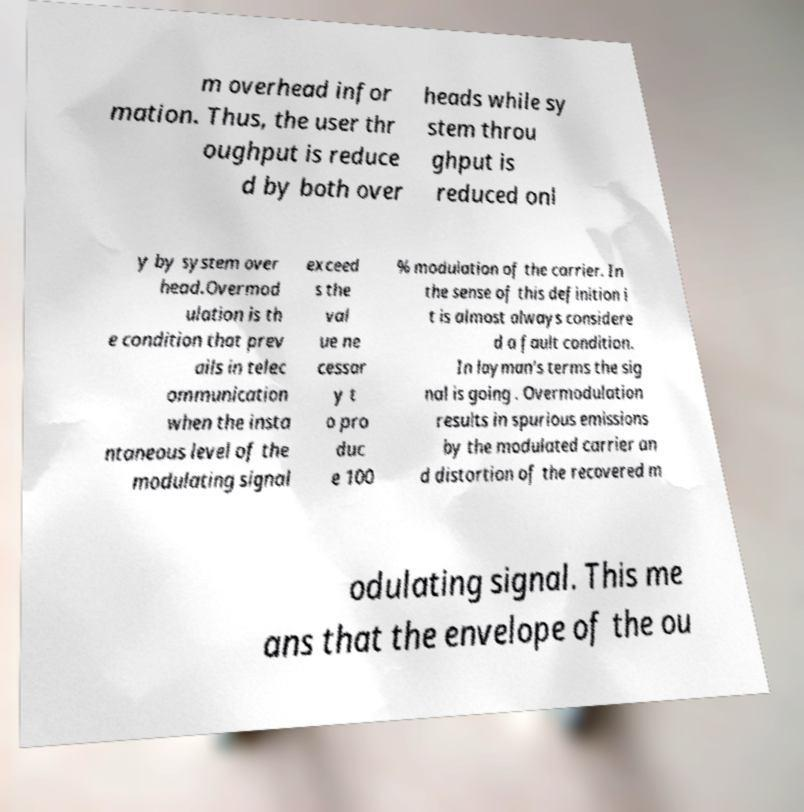I need the written content from this picture converted into text. Can you do that? m overhead infor mation. Thus, the user thr oughput is reduce d by both over heads while sy stem throu ghput is reduced onl y by system over head.Overmod ulation is th e condition that prev ails in telec ommunication when the insta ntaneous level of the modulating signal exceed s the val ue ne cessar y t o pro duc e 100 % modulation of the carrier. In the sense of this definition i t is almost always considere d a fault condition. In layman's terms the sig nal is going . Overmodulation results in spurious emissions by the modulated carrier an d distortion of the recovered m odulating signal. This me ans that the envelope of the ou 